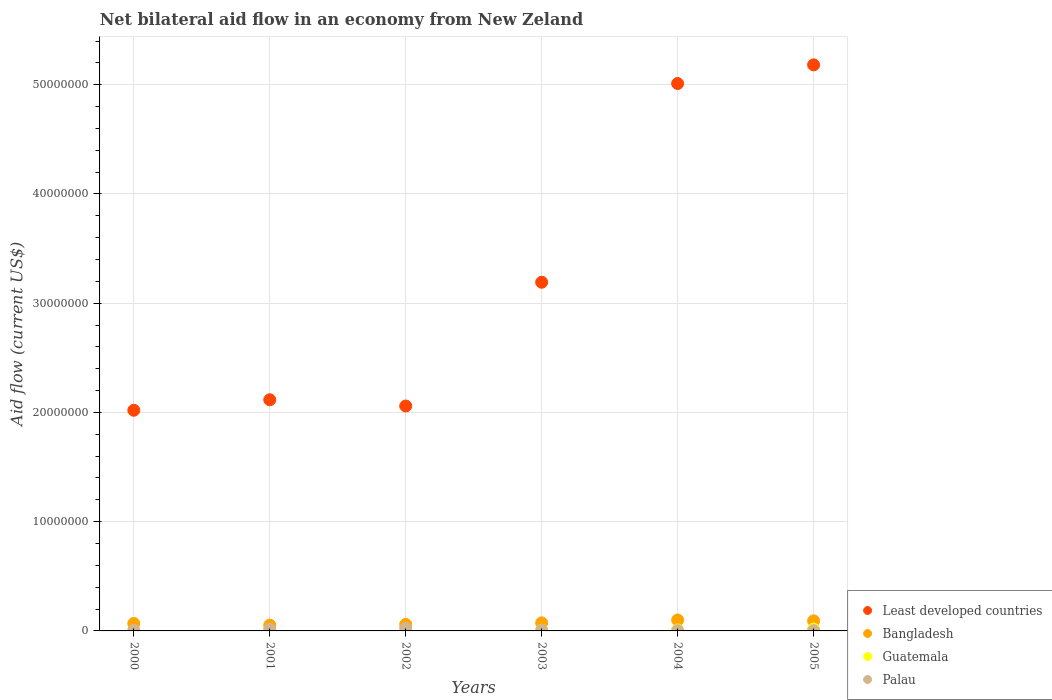Is the number of dotlines equal to the number of legend labels?
Provide a short and direct response. Yes. What is the net bilateral aid flow in Least developed countries in 2000?
Provide a succinct answer. 2.02e+07. Across all years, what is the maximum net bilateral aid flow in Least developed countries?
Give a very brief answer. 5.18e+07. In which year was the net bilateral aid flow in Least developed countries minimum?
Your response must be concise. 2000. What is the total net bilateral aid flow in Palau in the graph?
Your response must be concise. 5.70e+05. What is the difference between the net bilateral aid flow in Least developed countries in 2000 and that in 2005?
Provide a succinct answer. -3.16e+07. What is the difference between the net bilateral aid flow in Guatemala in 2004 and the net bilateral aid flow in Least developed countries in 2005?
Offer a very short reply. -5.17e+07. What is the average net bilateral aid flow in Guatemala per year?
Ensure brevity in your answer.  7.67e+04. In the year 2005, what is the difference between the net bilateral aid flow in Bangladesh and net bilateral aid flow in Palau?
Provide a succinct answer. 8.90e+05. In how many years, is the net bilateral aid flow in Palau greater than 42000000 US$?
Provide a short and direct response. 0. What is the ratio of the net bilateral aid flow in Least developed countries in 2000 to that in 2004?
Give a very brief answer. 0.4. Is the difference between the net bilateral aid flow in Bangladesh in 2000 and 2001 greater than the difference between the net bilateral aid flow in Palau in 2000 and 2001?
Ensure brevity in your answer.  Yes. What is the difference between the highest and the second highest net bilateral aid flow in Least developed countries?
Your response must be concise. 1.71e+06. What is the difference between the highest and the lowest net bilateral aid flow in Palau?
Your response must be concise. 2.10e+05. In how many years, is the net bilateral aid flow in Palau greater than the average net bilateral aid flow in Palau taken over all years?
Your response must be concise. 2. Is it the case that in every year, the sum of the net bilateral aid flow in Palau and net bilateral aid flow in Least developed countries  is greater than the sum of net bilateral aid flow in Bangladesh and net bilateral aid flow in Guatemala?
Ensure brevity in your answer.  Yes. Is it the case that in every year, the sum of the net bilateral aid flow in Palau and net bilateral aid flow in Bangladesh  is greater than the net bilateral aid flow in Least developed countries?
Keep it short and to the point. No. Is the net bilateral aid flow in Least developed countries strictly greater than the net bilateral aid flow in Guatemala over the years?
Give a very brief answer. Yes. Is the net bilateral aid flow in Palau strictly less than the net bilateral aid flow in Bangladesh over the years?
Offer a terse response. Yes. How many dotlines are there?
Your answer should be very brief. 4. How many years are there in the graph?
Offer a very short reply. 6. Does the graph contain grids?
Ensure brevity in your answer.  Yes. Where does the legend appear in the graph?
Your answer should be very brief. Bottom right. How are the legend labels stacked?
Your answer should be very brief. Vertical. What is the title of the graph?
Provide a short and direct response. Net bilateral aid flow in an economy from New Zeland. Does "Ecuador" appear as one of the legend labels in the graph?
Provide a short and direct response. No. What is the label or title of the X-axis?
Offer a terse response. Years. What is the Aid flow (current US$) of Least developed countries in 2000?
Ensure brevity in your answer.  2.02e+07. What is the Aid flow (current US$) of Bangladesh in 2000?
Keep it short and to the point. 6.80e+05. What is the Aid flow (current US$) of Guatemala in 2000?
Your answer should be compact. 3.00e+04. What is the Aid flow (current US$) in Palau in 2000?
Your answer should be very brief. 5.00e+04. What is the Aid flow (current US$) in Least developed countries in 2001?
Your answer should be compact. 2.12e+07. What is the Aid flow (current US$) in Bangladesh in 2001?
Provide a succinct answer. 5.30e+05. What is the Aid flow (current US$) in Guatemala in 2001?
Offer a very short reply. 7.00e+04. What is the Aid flow (current US$) of Least developed countries in 2002?
Offer a very short reply. 2.06e+07. What is the Aid flow (current US$) of Guatemala in 2002?
Keep it short and to the point. 4.00e+04. What is the Aid flow (current US$) in Least developed countries in 2003?
Your response must be concise. 3.19e+07. What is the Aid flow (current US$) of Bangladesh in 2003?
Offer a terse response. 7.40e+05. What is the Aid flow (current US$) in Guatemala in 2003?
Provide a succinct answer. 6.00e+04. What is the Aid flow (current US$) of Least developed countries in 2004?
Your answer should be compact. 5.01e+07. What is the Aid flow (current US$) in Bangladesh in 2004?
Make the answer very short. 1.00e+06. What is the Aid flow (current US$) in Guatemala in 2004?
Your response must be concise. 9.00e+04. What is the Aid flow (current US$) of Palau in 2004?
Your response must be concise. 3.00e+04. What is the Aid flow (current US$) in Least developed countries in 2005?
Your response must be concise. 5.18e+07. What is the Aid flow (current US$) in Bangladesh in 2005?
Keep it short and to the point. 9.20e+05. What is the Aid flow (current US$) of Palau in 2005?
Your answer should be compact. 3.00e+04. Across all years, what is the maximum Aid flow (current US$) in Least developed countries?
Make the answer very short. 5.18e+07. Across all years, what is the maximum Aid flow (current US$) in Bangladesh?
Your answer should be compact. 1.00e+06. Across all years, what is the maximum Aid flow (current US$) in Guatemala?
Your answer should be very brief. 1.70e+05. Across all years, what is the minimum Aid flow (current US$) of Least developed countries?
Your answer should be very brief. 2.02e+07. Across all years, what is the minimum Aid flow (current US$) of Bangladesh?
Offer a very short reply. 5.30e+05. Across all years, what is the minimum Aid flow (current US$) in Guatemala?
Keep it short and to the point. 3.00e+04. What is the total Aid flow (current US$) of Least developed countries in the graph?
Your response must be concise. 1.96e+08. What is the total Aid flow (current US$) of Bangladesh in the graph?
Offer a terse response. 4.47e+06. What is the total Aid flow (current US$) of Guatemala in the graph?
Provide a succinct answer. 4.60e+05. What is the total Aid flow (current US$) in Palau in the graph?
Give a very brief answer. 5.70e+05. What is the difference between the Aid flow (current US$) of Least developed countries in 2000 and that in 2001?
Provide a succinct answer. -9.60e+05. What is the difference between the Aid flow (current US$) of Guatemala in 2000 and that in 2001?
Ensure brevity in your answer.  -4.00e+04. What is the difference between the Aid flow (current US$) of Least developed countries in 2000 and that in 2002?
Offer a terse response. -3.90e+05. What is the difference between the Aid flow (current US$) of Least developed countries in 2000 and that in 2003?
Your answer should be compact. -1.17e+07. What is the difference between the Aid flow (current US$) in Bangladesh in 2000 and that in 2003?
Make the answer very short. -6.00e+04. What is the difference between the Aid flow (current US$) in Least developed countries in 2000 and that in 2004?
Your answer should be compact. -2.99e+07. What is the difference between the Aid flow (current US$) in Bangladesh in 2000 and that in 2004?
Your response must be concise. -3.20e+05. What is the difference between the Aid flow (current US$) of Palau in 2000 and that in 2004?
Your answer should be compact. 2.00e+04. What is the difference between the Aid flow (current US$) of Least developed countries in 2000 and that in 2005?
Give a very brief answer. -3.16e+07. What is the difference between the Aid flow (current US$) in Guatemala in 2000 and that in 2005?
Your answer should be very brief. -1.40e+05. What is the difference between the Aid flow (current US$) in Least developed countries in 2001 and that in 2002?
Keep it short and to the point. 5.70e+05. What is the difference between the Aid flow (current US$) in Bangladesh in 2001 and that in 2002?
Ensure brevity in your answer.  -7.00e+04. What is the difference between the Aid flow (current US$) of Least developed countries in 2001 and that in 2003?
Provide a short and direct response. -1.08e+07. What is the difference between the Aid flow (current US$) in Guatemala in 2001 and that in 2003?
Your response must be concise. 10000. What is the difference between the Aid flow (current US$) in Least developed countries in 2001 and that in 2004?
Make the answer very short. -2.90e+07. What is the difference between the Aid flow (current US$) of Bangladesh in 2001 and that in 2004?
Ensure brevity in your answer.  -4.70e+05. What is the difference between the Aid flow (current US$) in Palau in 2001 and that in 2004?
Ensure brevity in your answer.  1.30e+05. What is the difference between the Aid flow (current US$) of Least developed countries in 2001 and that in 2005?
Ensure brevity in your answer.  -3.07e+07. What is the difference between the Aid flow (current US$) of Bangladesh in 2001 and that in 2005?
Offer a very short reply. -3.90e+05. What is the difference between the Aid flow (current US$) of Least developed countries in 2002 and that in 2003?
Ensure brevity in your answer.  -1.13e+07. What is the difference between the Aid flow (current US$) in Guatemala in 2002 and that in 2003?
Your response must be concise. -2.00e+04. What is the difference between the Aid flow (current US$) in Palau in 2002 and that in 2003?
Your answer should be compact. 1.80e+05. What is the difference between the Aid flow (current US$) in Least developed countries in 2002 and that in 2004?
Provide a succinct answer. -2.95e+07. What is the difference between the Aid flow (current US$) in Bangladesh in 2002 and that in 2004?
Offer a terse response. -4.00e+05. What is the difference between the Aid flow (current US$) of Guatemala in 2002 and that in 2004?
Your answer should be very brief. -5.00e+04. What is the difference between the Aid flow (current US$) of Palau in 2002 and that in 2004?
Your response must be concise. 2.10e+05. What is the difference between the Aid flow (current US$) in Least developed countries in 2002 and that in 2005?
Your answer should be compact. -3.12e+07. What is the difference between the Aid flow (current US$) of Bangladesh in 2002 and that in 2005?
Offer a terse response. -3.20e+05. What is the difference between the Aid flow (current US$) in Guatemala in 2002 and that in 2005?
Offer a very short reply. -1.30e+05. What is the difference between the Aid flow (current US$) of Palau in 2002 and that in 2005?
Your answer should be very brief. 2.10e+05. What is the difference between the Aid flow (current US$) of Least developed countries in 2003 and that in 2004?
Provide a succinct answer. -1.82e+07. What is the difference between the Aid flow (current US$) of Bangladesh in 2003 and that in 2004?
Your response must be concise. -2.60e+05. What is the difference between the Aid flow (current US$) in Palau in 2003 and that in 2004?
Your answer should be very brief. 3.00e+04. What is the difference between the Aid flow (current US$) in Least developed countries in 2003 and that in 2005?
Offer a very short reply. -1.99e+07. What is the difference between the Aid flow (current US$) of Bangladesh in 2003 and that in 2005?
Make the answer very short. -1.80e+05. What is the difference between the Aid flow (current US$) in Least developed countries in 2004 and that in 2005?
Your answer should be very brief. -1.71e+06. What is the difference between the Aid flow (current US$) in Bangladesh in 2004 and that in 2005?
Offer a terse response. 8.00e+04. What is the difference between the Aid flow (current US$) of Guatemala in 2004 and that in 2005?
Your answer should be compact. -8.00e+04. What is the difference between the Aid flow (current US$) in Palau in 2004 and that in 2005?
Keep it short and to the point. 0. What is the difference between the Aid flow (current US$) of Least developed countries in 2000 and the Aid flow (current US$) of Bangladesh in 2001?
Offer a terse response. 1.97e+07. What is the difference between the Aid flow (current US$) of Least developed countries in 2000 and the Aid flow (current US$) of Guatemala in 2001?
Ensure brevity in your answer.  2.01e+07. What is the difference between the Aid flow (current US$) in Least developed countries in 2000 and the Aid flow (current US$) in Palau in 2001?
Ensure brevity in your answer.  2.00e+07. What is the difference between the Aid flow (current US$) in Bangladesh in 2000 and the Aid flow (current US$) in Palau in 2001?
Offer a very short reply. 5.20e+05. What is the difference between the Aid flow (current US$) in Guatemala in 2000 and the Aid flow (current US$) in Palau in 2001?
Ensure brevity in your answer.  -1.30e+05. What is the difference between the Aid flow (current US$) of Least developed countries in 2000 and the Aid flow (current US$) of Bangladesh in 2002?
Your answer should be very brief. 1.96e+07. What is the difference between the Aid flow (current US$) in Least developed countries in 2000 and the Aid flow (current US$) in Guatemala in 2002?
Your response must be concise. 2.02e+07. What is the difference between the Aid flow (current US$) of Least developed countries in 2000 and the Aid flow (current US$) of Palau in 2002?
Provide a short and direct response. 2.00e+07. What is the difference between the Aid flow (current US$) of Bangladesh in 2000 and the Aid flow (current US$) of Guatemala in 2002?
Ensure brevity in your answer.  6.40e+05. What is the difference between the Aid flow (current US$) in Least developed countries in 2000 and the Aid flow (current US$) in Bangladesh in 2003?
Make the answer very short. 1.95e+07. What is the difference between the Aid flow (current US$) of Least developed countries in 2000 and the Aid flow (current US$) of Guatemala in 2003?
Ensure brevity in your answer.  2.01e+07. What is the difference between the Aid flow (current US$) in Least developed countries in 2000 and the Aid flow (current US$) in Palau in 2003?
Offer a terse response. 2.01e+07. What is the difference between the Aid flow (current US$) of Bangladesh in 2000 and the Aid flow (current US$) of Guatemala in 2003?
Offer a very short reply. 6.20e+05. What is the difference between the Aid flow (current US$) in Bangladesh in 2000 and the Aid flow (current US$) in Palau in 2003?
Your answer should be compact. 6.20e+05. What is the difference between the Aid flow (current US$) in Guatemala in 2000 and the Aid flow (current US$) in Palau in 2003?
Your answer should be very brief. -3.00e+04. What is the difference between the Aid flow (current US$) in Least developed countries in 2000 and the Aid flow (current US$) in Bangladesh in 2004?
Give a very brief answer. 1.92e+07. What is the difference between the Aid flow (current US$) of Least developed countries in 2000 and the Aid flow (current US$) of Guatemala in 2004?
Make the answer very short. 2.01e+07. What is the difference between the Aid flow (current US$) of Least developed countries in 2000 and the Aid flow (current US$) of Palau in 2004?
Your response must be concise. 2.02e+07. What is the difference between the Aid flow (current US$) in Bangladesh in 2000 and the Aid flow (current US$) in Guatemala in 2004?
Provide a short and direct response. 5.90e+05. What is the difference between the Aid flow (current US$) in Bangladesh in 2000 and the Aid flow (current US$) in Palau in 2004?
Give a very brief answer. 6.50e+05. What is the difference between the Aid flow (current US$) of Guatemala in 2000 and the Aid flow (current US$) of Palau in 2004?
Provide a succinct answer. 0. What is the difference between the Aid flow (current US$) of Least developed countries in 2000 and the Aid flow (current US$) of Bangladesh in 2005?
Give a very brief answer. 1.93e+07. What is the difference between the Aid flow (current US$) of Least developed countries in 2000 and the Aid flow (current US$) of Guatemala in 2005?
Your answer should be compact. 2.00e+07. What is the difference between the Aid flow (current US$) in Least developed countries in 2000 and the Aid flow (current US$) in Palau in 2005?
Give a very brief answer. 2.02e+07. What is the difference between the Aid flow (current US$) in Bangladesh in 2000 and the Aid flow (current US$) in Guatemala in 2005?
Provide a short and direct response. 5.10e+05. What is the difference between the Aid flow (current US$) in Bangladesh in 2000 and the Aid flow (current US$) in Palau in 2005?
Your response must be concise. 6.50e+05. What is the difference between the Aid flow (current US$) in Guatemala in 2000 and the Aid flow (current US$) in Palau in 2005?
Your answer should be very brief. 0. What is the difference between the Aid flow (current US$) of Least developed countries in 2001 and the Aid flow (current US$) of Bangladesh in 2002?
Provide a succinct answer. 2.06e+07. What is the difference between the Aid flow (current US$) in Least developed countries in 2001 and the Aid flow (current US$) in Guatemala in 2002?
Make the answer very short. 2.11e+07. What is the difference between the Aid flow (current US$) of Least developed countries in 2001 and the Aid flow (current US$) of Palau in 2002?
Give a very brief answer. 2.09e+07. What is the difference between the Aid flow (current US$) in Bangladesh in 2001 and the Aid flow (current US$) in Guatemala in 2002?
Provide a succinct answer. 4.90e+05. What is the difference between the Aid flow (current US$) of Bangladesh in 2001 and the Aid flow (current US$) of Palau in 2002?
Provide a succinct answer. 2.90e+05. What is the difference between the Aid flow (current US$) of Least developed countries in 2001 and the Aid flow (current US$) of Bangladesh in 2003?
Offer a very short reply. 2.04e+07. What is the difference between the Aid flow (current US$) of Least developed countries in 2001 and the Aid flow (current US$) of Guatemala in 2003?
Make the answer very short. 2.11e+07. What is the difference between the Aid flow (current US$) in Least developed countries in 2001 and the Aid flow (current US$) in Palau in 2003?
Offer a terse response. 2.11e+07. What is the difference between the Aid flow (current US$) of Bangladesh in 2001 and the Aid flow (current US$) of Palau in 2003?
Keep it short and to the point. 4.70e+05. What is the difference between the Aid flow (current US$) of Guatemala in 2001 and the Aid flow (current US$) of Palau in 2003?
Keep it short and to the point. 10000. What is the difference between the Aid flow (current US$) in Least developed countries in 2001 and the Aid flow (current US$) in Bangladesh in 2004?
Give a very brief answer. 2.02e+07. What is the difference between the Aid flow (current US$) of Least developed countries in 2001 and the Aid flow (current US$) of Guatemala in 2004?
Your response must be concise. 2.11e+07. What is the difference between the Aid flow (current US$) in Least developed countries in 2001 and the Aid flow (current US$) in Palau in 2004?
Offer a very short reply. 2.11e+07. What is the difference between the Aid flow (current US$) of Bangladesh in 2001 and the Aid flow (current US$) of Palau in 2004?
Your response must be concise. 5.00e+05. What is the difference between the Aid flow (current US$) of Guatemala in 2001 and the Aid flow (current US$) of Palau in 2004?
Offer a terse response. 4.00e+04. What is the difference between the Aid flow (current US$) in Least developed countries in 2001 and the Aid flow (current US$) in Bangladesh in 2005?
Offer a terse response. 2.02e+07. What is the difference between the Aid flow (current US$) of Least developed countries in 2001 and the Aid flow (current US$) of Guatemala in 2005?
Offer a very short reply. 2.10e+07. What is the difference between the Aid flow (current US$) in Least developed countries in 2001 and the Aid flow (current US$) in Palau in 2005?
Ensure brevity in your answer.  2.11e+07. What is the difference between the Aid flow (current US$) in Bangladesh in 2001 and the Aid flow (current US$) in Guatemala in 2005?
Provide a short and direct response. 3.60e+05. What is the difference between the Aid flow (current US$) in Bangladesh in 2001 and the Aid flow (current US$) in Palau in 2005?
Make the answer very short. 5.00e+05. What is the difference between the Aid flow (current US$) in Guatemala in 2001 and the Aid flow (current US$) in Palau in 2005?
Keep it short and to the point. 4.00e+04. What is the difference between the Aid flow (current US$) of Least developed countries in 2002 and the Aid flow (current US$) of Bangladesh in 2003?
Give a very brief answer. 1.98e+07. What is the difference between the Aid flow (current US$) of Least developed countries in 2002 and the Aid flow (current US$) of Guatemala in 2003?
Offer a very short reply. 2.05e+07. What is the difference between the Aid flow (current US$) in Least developed countries in 2002 and the Aid flow (current US$) in Palau in 2003?
Provide a succinct answer. 2.05e+07. What is the difference between the Aid flow (current US$) of Bangladesh in 2002 and the Aid flow (current US$) of Guatemala in 2003?
Your answer should be very brief. 5.40e+05. What is the difference between the Aid flow (current US$) of Bangladesh in 2002 and the Aid flow (current US$) of Palau in 2003?
Offer a terse response. 5.40e+05. What is the difference between the Aid flow (current US$) of Guatemala in 2002 and the Aid flow (current US$) of Palau in 2003?
Keep it short and to the point. -2.00e+04. What is the difference between the Aid flow (current US$) in Least developed countries in 2002 and the Aid flow (current US$) in Bangladesh in 2004?
Make the answer very short. 1.96e+07. What is the difference between the Aid flow (current US$) in Least developed countries in 2002 and the Aid flow (current US$) in Guatemala in 2004?
Keep it short and to the point. 2.05e+07. What is the difference between the Aid flow (current US$) in Least developed countries in 2002 and the Aid flow (current US$) in Palau in 2004?
Make the answer very short. 2.06e+07. What is the difference between the Aid flow (current US$) of Bangladesh in 2002 and the Aid flow (current US$) of Guatemala in 2004?
Offer a very short reply. 5.10e+05. What is the difference between the Aid flow (current US$) in Bangladesh in 2002 and the Aid flow (current US$) in Palau in 2004?
Make the answer very short. 5.70e+05. What is the difference between the Aid flow (current US$) of Least developed countries in 2002 and the Aid flow (current US$) of Bangladesh in 2005?
Keep it short and to the point. 1.97e+07. What is the difference between the Aid flow (current US$) in Least developed countries in 2002 and the Aid flow (current US$) in Guatemala in 2005?
Offer a terse response. 2.04e+07. What is the difference between the Aid flow (current US$) in Least developed countries in 2002 and the Aid flow (current US$) in Palau in 2005?
Offer a very short reply. 2.06e+07. What is the difference between the Aid flow (current US$) in Bangladesh in 2002 and the Aid flow (current US$) in Palau in 2005?
Provide a short and direct response. 5.70e+05. What is the difference between the Aid flow (current US$) in Guatemala in 2002 and the Aid flow (current US$) in Palau in 2005?
Your response must be concise. 10000. What is the difference between the Aid flow (current US$) of Least developed countries in 2003 and the Aid flow (current US$) of Bangladesh in 2004?
Provide a short and direct response. 3.09e+07. What is the difference between the Aid flow (current US$) of Least developed countries in 2003 and the Aid flow (current US$) of Guatemala in 2004?
Provide a short and direct response. 3.18e+07. What is the difference between the Aid flow (current US$) in Least developed countries in 2003 and the Aid flow (current US$) in Palau in 2004?
Provide a short and direct response. 3.19e+07. What is the difference between the Aid flow (current US$) of Bangladesh in 2003 and the Aid flow (current US$) of Guatemala in 2004?
Provide a succinct answer. 6.50e+05. What is the difference between the Aid flow (current US$) of Bangladesh in 2003 and the Aid flow (current US$) of Palau in 2004?
Your response must be concise. 7.10e+05. What is the difference between the Aid flow (current US$) in Least developed countries in 2003 and the Aid flow (current US$) in Bangladesh in 2005?
Your answer should be very brief. 3.10e+07. What is the difference between the Aid flow (current US$) of Least developed countries in 2003 and the Aid flow (current US$) of Guatemala in 2005?
Ensure brevity in your answer.  3.18e+07. What is the difference between the Aid flow (current US$) in Least developed countries in 2003 and the Aid flow (current US$) in Palau in 2005?
Keep it short and to the point. 3.19e+07. What is the difference between the Aid flow (current US$) in Bangladesh in 2003 and the Aid flow (current US$) in Guatemala in 2005?
Ensure brevity in your answer.  5.70e+05. What is the difference between the Aid flow (current US$) in Bangladesh in 2003 and the Aid flow (current US$) in Palau in 2005?
Provide a short and direct response. 7.10e+05. What is the difference between the Aid flow (current US$) in Guatemala in 2003 and the Aid flow (current US$) in Palau in 2005?
Your response must be concise. 3.00e+04. What is the difference between the Aid flow (current US$) of Least developed countries in 2004 and the Aid flow (current US$) of Bangladesh in 2005?
Keep it short and to the point. 4.92e+07. What is the difference between the Aid flow (current US$) of Least developed countries in 2004 and the Aid flow (current US$) of Guatemala in 2005?
Ensure brevity in your answer.  4.99e+07. What is the difference between the Aid flow (current US$) of Least developed countries in 2004 and the Aid flow (current US$) of Palau in 2005?
Make the answer very short. 5.01e+07. What is the difference between the Aid flow (current US$) of Bangladesh in 2004 and the Aid flow (current US$) of Guatemala in 2005?
Your answer should be very brief. 8.30e+05. What is the difference between the Aid flow (current US$) of Bangladesh in 2004 and the Aid flow (current US$) of Palau in 2005?
Your answer should be very brief. 9.70e+05. What is the difference between the Aid flow (current US$) in Guatemala in 2004 and the Aid flow (current US$) in Palau in 2005?
Give a very brief answer. 6.00e+04. What is the average Aid flow (current US$) of Least developed countries per year?
Give a very brief answer. 3.26e+07. What is the average Aid flow (current US$) of Bangladesh per year?
Provide a succinct answer. 7.45e+05. What is the average Aid flow (current US$) in Guatemala per year?
Your answer should be compact. 7.67e+04. What is the average Aid flow (current US$) in Palau per year?
Your answer should be very brief. 9.50e+04. In the year 2000, what is the difference between the Aid flow (current US$) of Least developed countries and Aid flow (current US$) of Bangladesh?
Make the answer very short. 1.95e+07. In the year 2000, what is the difference between the Aid flow (current US$) in Least developed countries and Aid flow (current US$) in Guatemala?
Your answer should be compact. 2.02e+07. In the year 2000, what is the difference between the Aid flow (current US$) of Least developed countries and Aid flow (current US$) of Palau?
Provide a succinct answer. 2.02e+07. In the year 2000, what is the difference between the Aid flow (current US$) in Bangladesh and Aid flow (current US$) in Guatemala?
Provide a short and direct response. 6.50e+05. In the year 2000, what is the difference between the Aid flow (current US$) in Bangladesh and Aid flow (current US$) in Palau?
Offer a very short reply. 6.30e+05. In the year 2000, what is the difference between the Aid flow (current US$) of Guatemala and Aid flow (current US$) of Palau?
Keep it short and to the point. -2.00e+04. In the year 2001, what is the difference between the Aid flow (current US$) in Least developed countries and Aid flow (current US$) in Bangladesh?
Keep it short and to the point. 2.06e+07. In the year 2001, what is the difference between the Aid flow (current US$) of Least developed countries and Aid flow (current US$) of Guatemala?
Keep it short and to the point. 2.11e+07. In the year 2001, what is the difference between the Aid flow (current US$) of Least developed countries and Aid flow (current US$) of Palau?
Make the answer very short. 2.10e+07. In the year 2001, what is the difference between the Aid flow (current US$) of Guatemala and Aid flow (current US$) of Palau?
Your answer should be very brief. -9.00e+04. In the year 2002, what is the difference between the Aid flow (current US$) of Least developed countries and Aid flow (current US$) of Bangladesh?
Make the answer very short. 2.00e+07. In the year 2002, what is the difference between the Aid flow (current US$) of Least developed countries and Aid flow (current US$) of Guatemala?
Make the answer very short. 2.06e+07. In the year 2002, what is the difference between the Aid flow (current US$) in Least developed countries and Aid flow (current US$) in Palau?
Your answer should be compact. 2.04e+07. In the year 2002, what is the difference between the Aid flow (current US$) in Bangladesh and Aid flow (current US$) in Guatemala?
Your response must be concise. 5.60e+05. In the year 2002, what is the difference between the Aid flow (current US$) of Bangladesh and Aid flow (current US$) of Palau?
Your answer should be compact. 3.60e+05. In the year 2003, what is the difference between the Aid flow (current US$) in Least developed countries and Aid flow (current US$) in Bangladesh?
Offer a terse response. 3.12e+07. In the year 2003, what is the difference between the Aid flow (current US$) in Least developed countries and Aid flow (current US$) in Guatemala?
Keep it short and to the point. 3.19e+07. In the year 2003, what is the difference between the Aid flow (current US$) of Least developed countries and Aid flow (current US$) of Palau?
Offer a very short reply. 3.19e+07. In the year 2003, what is the difference between the Aid flow (current US$) in Bangladesh and Aid flow (current US$) in Guatemala?
Provide a short and direct response. 6.80e+05. In the year 2003, what is the difference between the Aid flow (current US$) in Bangladesh and Aid flow (current US$) in Palau?
Make the answer very short. 6.80e+05. In the year 2003, what is the difference between the Aid flow (current US$) of Guatemala and Aid flow (current US$) of Palau?
Provide a short and direct response. 0. In the year 2004, what is the difference between the Aid flow (current US$) of Least developed countries and Aid flow (current US$) of Bangladesh?
Keep it short and to the point. 4.91e+07. In the year 2004, what is the difference between the Aid flow (current US$) of Least developed countries and Aid flow (current US$) of Guatemala?
Give a very brief answer. 5.00e+07. In the year 2004, what is the difference between the Aid flow (current US$) in Least developed countries and Aid flow (current US$) in Palau?
Your answer should be very brief. 5.01e+07. In the year 2004, what is the difference between the Aid flow (current US$) of Bangladesh and Aid flow (current US$) of Guatemala?
Ensure brevity in your answer.  9.10e+05. In the year 2004, what is the difference between the Aid flow (current US$) of Bangladesh and Aid flow (current US$) of Palau?
Offer a terse response. 9.70e+05. In the year 2005, what is the difference between the Aid flow (current US$) of Least developed countries and Aid flow (current US$) of Bangladesh?
Make the answer very short. 5.09e+07. In the year 2005, what is the difference between the Aid flow (current US$) of Least developed countries and Aid flow (current US$) of Guatemala?
Offer a terse response. 5.16e+07. In the year 2005, what is the difference between the Aid flow (current US$) of Least developed countries and Aid flow (current US$) of Palau?
Your answer should be very brief. 5.18e+07. In the year 2005, what is the difference between the Aid flow (current US$) of Bangladesh and Aid flow (current US$) of Guatemala?
Give a very brief answer. 7.50e+05. In the year 2005, what is the difference between the Aid flow (current US$) of Bangladesh and Aid flow (current US$) of Palau?
Make the answer very short. 8.90e+05. What is the ratio of the Aid flow (current US$) in Least developed countries in 2000 to that in 2001?
Offer a terse response. 0.95. What is the ratio of the Aid flow (current US$) of Bangladesh in 2000 to that in 2001?
Give a very brief answer. 1.28. What is the ratio of the Aid flow (current US$) in Guatemala in 2000 to that in 2001?
Your answer should be compact. 0.43. What is the ratio of the Aid flow (current US$) in Palau in 2000 to that in 2001?
Ensure brevity in your answer.  0.31. What is the ratio of the Aid flow (current US$) of Least developed countries in 2000 to that in 2002?
Provide a succinct answer. 0.98. What is the ratio of the Aid flow (current US$) of Bangladesh in 2000 to that in 2002?
Give a very brief answer. 1.13. What is the ratio of the Aid flow (current US$) in Palau in 2000 to that in 2002?
Ensure brevity in your answer.  0.21. What is the ratio of the Aid flow (current US$) of Least developed countries in 2000 to that in 2003?
Provide a short and direct response. 0.63. What is the ratio of the Aid flow (current US$) in Bangladesh in 2000 to that in 2003?
Your response must be concise. 0.92. What is the ratio of the Aid flow (current US$) in Palau in 2000 to that in 2003?
Offer a very short reply. 0.83. What is the ratio of the Aid flow (current US$) of Least developed countries in 2000 to that in 2004?
Provide a succinct answer. 0.4. What is the ratio of the Aid flow (current US$) in Bangladesh in 2000 to that in 2004?
Keep it short and to the point. 0.68. What is the ratio of the Aid flow (current US$) of Palau in 2000 to that in 2004?
Offer a terse response. 1.67. What is the ratio of the Aid flow (current US$) of Least developed countries in 2000 to that in 2005?
Offer a terse response. 0.39. What is the ratio of the Aid flow (current US$) in Bangladesh in 2000 to that in 2005?
Give a very brief answer. 0.74. What is the ratio of the Aid flow (current US$) of Guatemala in 2000 to that in 2005?
Give a very brief answer. 0.18. What is the ratio of the Aid flow (current US$) of Palau in 2000 to that in 2005?
Your answer should be compact. 1.67. What is the ratio of the Aid flow (current US$) of Least developed countries in 2001 to that in 2002?
Provide a succinct answer. 1.03. What is the ratio of the Aid flow (current US$) of Bangladesh in 2001 to that in 2002?
Make the answer very short. 0.88. What is the ratio of the Aid flow (current US$) of Guatemala in 2001 to that in 2002?
Offer a very short reply. 1.75. What is the ratio of the Aid flow (current US$) in Least developed countries in 2001 to that in 2003?
Provide a succinct answer. 0.66. What is the ratio of the Aid flow (current US$) in Bangladesh in 2001 to that in 2003?
Make the answer very short. 0.72. What is the ratio of the Aid flow (current US$) of Palau in 2001 to that in 2003?
Provide a short and direct response. 2.67. What is the ratio of the Aid flow (current US$) in Least developed countries in 2001 to that in 2004?
Keep it short and to the point. 0.42. What is the ratio of the Aid flow (current US$) in Bangladesh in 2001 to that in 2004?
Make the answer very short. 0.53. What is the ratio of the Aid flow (current US$) of Palau in 2001 to that in 2004?
Offer a terse response. 5.33. What is the ratio of the Aid flow (current US$) of Least developed countries in 2001 to that in 2005?
Offer a terse response. 0.41. What is the ratio of the Aid flow (current US$) in Bangladesh in 2001 to that in 2005?
Provide a succinct answer. 0.58. What is the ratio of the Aid flow (current US$) in Guatemala in 2001 to that in 2005?
Provide a succinct answer. 0.41. What is the ratio of the Aid flow (current US$) in Palau in 2001 to that in 2005?
Make the answer very short. 5.33. What is the ratio of the Aid flow (current US$) in Least developed countries in 2002 to that in 2003?
Your answer should be compact. 0.65. What is the ratio of the Aid flow (current US$) in Bangladesh in 2002 to that in 2003?
Provide a short and direct response. 0.81. What is the ratio of the Aid flow (current US$) of Least developed countries in 2002 to that in 2004?
Make the answer very short. 0.41. What is the ratio of the Aid flow (current US$) in Guatemala in 2002 to that in 2004?
Your answer should be compact. 0.44. What is the ratio of the Aid flow (current US$) of Least developed countries in 2002 to that in 2005?
Offer a terse response. 0.4. What is the ratio of the Aid flow (current US$) of Bangladesh in 2002 to that in 2005?
Offer a terse response. 0.65. What is the ratio of the Aid flow (current US$) of Guatemala in 2002 to that in 2005?
Give a very brief answer. 0.24. What is the ratio of the Aid flow (current US$) of Palau in 2002 to that in 2005?
Provide a succinct answer. 8. What is the ratio of the Aid flow (current US$) of Least developed countries in 2003 to that in 2004?
Provide a short and direct response. 0.64. What is the ratio of the Aid flow (current US$) in Bangladesh in 2003 to that in 2004?
Your answer should be compact. 0.74. What is the ratio of the Aid flow (current US$) of Least developed countries in 2003 to that in 2005?
Provide a succinct answer. 0.62. What is the ratio of the Aid flow (current US$) in Bangladesh in 2003 to that in 2005?
Your answer should be very brief. 0.8. What is the ratio of the Aid flow (current US$) in Guatemala in 2003 to that in 2005?
Keep it short and to the point. 0.35. What is the ratio of the Aid flow (current US$) in Bangladesh in 2004 to that in 2005?
Give a very brief answer. 1.09. What is the ratio of the Aid flow (current US$) in Guatemala in 2004 to that in 2005?
Offer a terse response. 0.53. What is the ratio of the Aid flow (current US$) of Palau in 2004 to that in 2005?
Give a very brief answer. 1. What is the difference between the highest and the second highest Aid flow (current US$) in Least developed countries?
Provide a succinct answer. 1.71e+06. What is the difference between the highest and the second highest Aid flow (current US$) of Bangladesh?
Provide a short and direct response. 8.00e+04. What is the difference between the highest and the second highest Aid flow (current US$) in Guatemala?
Ensure brevity in your answer.  8.00e+04. What is the difference between the highest and the second highest Aid flow (current US$) of Palau?
Provide a succinct answer. 8.00e+04. What is the difference between the highest and the lowest Aid flow (current US$) in Least developed countries?
Make the answer very short. 3.16e+07. What is the difference between the highest and the lowest Aid flow (current US$) of Bangladesh?
Offer a very short reply. 4.70e+05. What is the difference between the highest and the lowest Aid flow (current US$) in Guatemala?
Make the answer very short. 1.40e+05. 